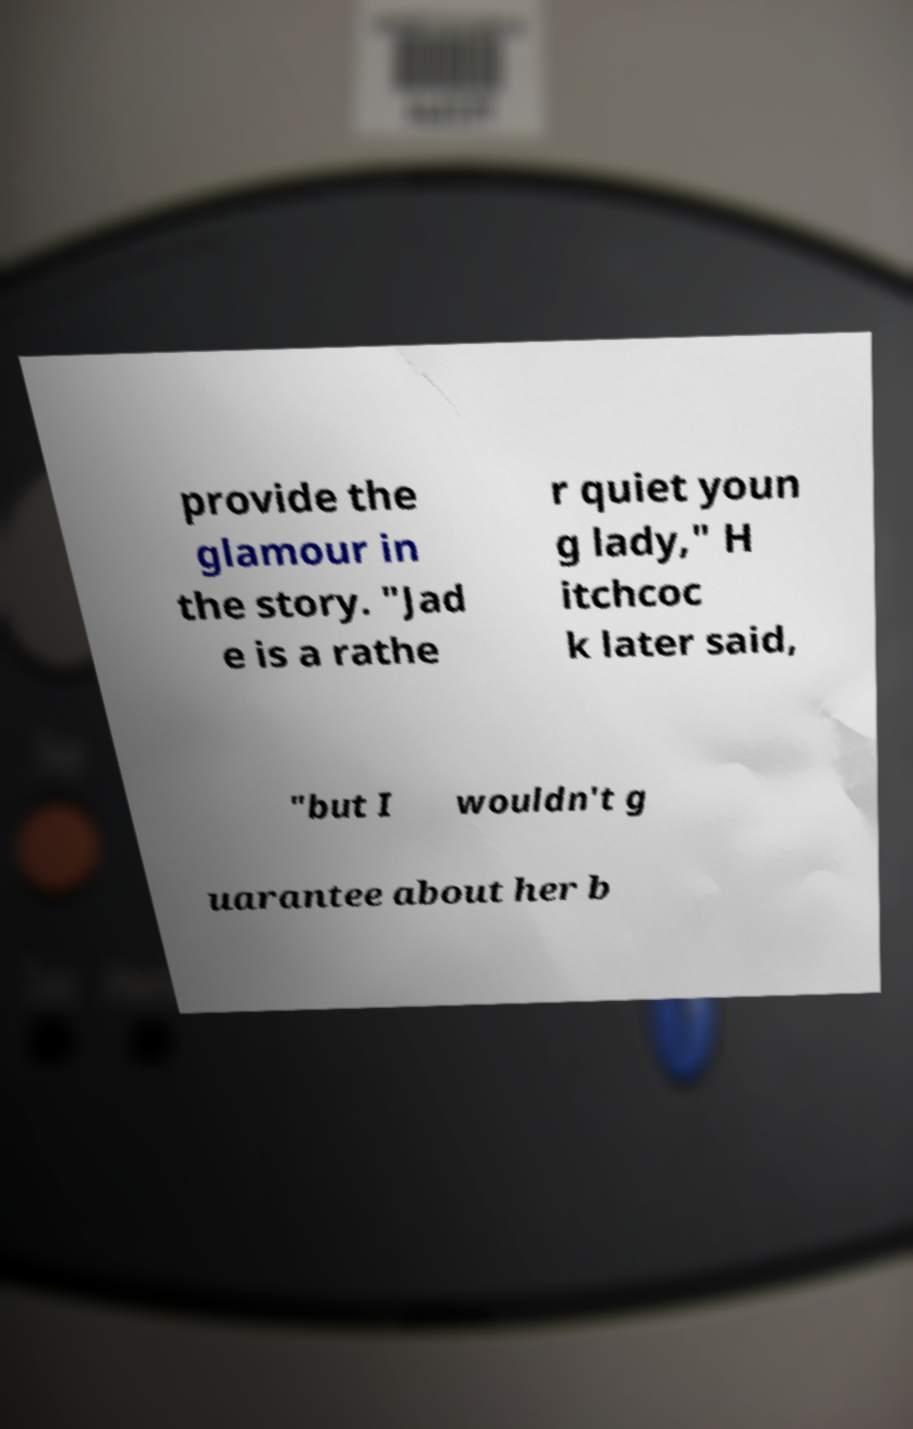For documentation purposes, I need the text within this image transcribed. Could you provide that? provide the glamour in the story. "Jad e is a rathe r quiet youn g lady," H itchcoc k later said, "but I wouldn't g uarantee about her b 